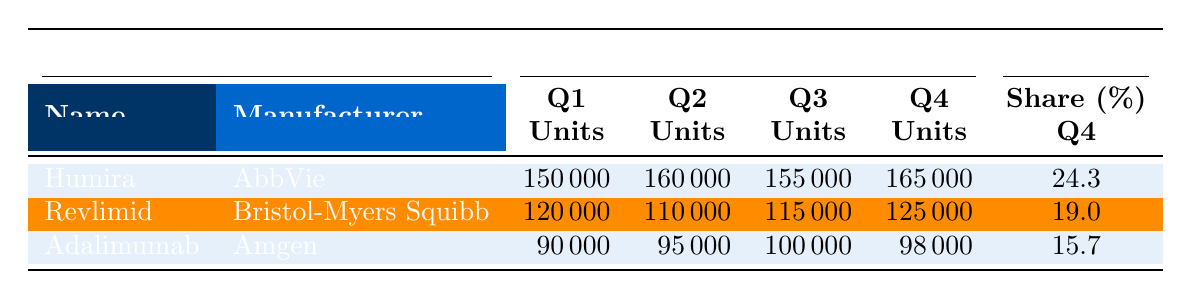What is the sales volume in units for Humira in Q2? The table indicates that the sales volume in units for Humira in Q2 is specifically listed under that quarter's column. The value for Humira in Q2 is 160,000 units.
Answer: 160,000 Which drug had the highest market share in Q4? The table shows that Humira has a market share of 24.3% in Q4, which is higher than the market shares for Revlimid (19.0%) and Adalimumab (15.7%). Therefore, Humira had the highest market share in Q4.
Answer: Humira What is the total sales volume in units for Revlimid over all four quarters? To find the total sales volume of Revlimid, add the units sold in each quarter: 120,000 (Q1) + 110,000 (Q2) + 115,000 (Q3) + 125,000 (Q4) = 470,000 units.
Answer: 470,000 Is the market share for Adalimumab consistent across all quarters? The market share for Adalimumab varies: 14.5% in Q1, 15.2% in Q2, 15.5% in Q3, and 15.7% in Q4. Since these values change, the market share is not consistent across all quarters.
Answer: No What is the percentage increase in sales volume units of Humira from Q1 to Q4? First, find the sales volume in Q1 (150,000 units) and Q4 (165,000 units). The increase is 165,000 - 150,000 = 15,000 units. To find the percentage increase: (15,000 / 150,000) * 100 = 10%.
Answer: 10% Which drug had the lowest sales volume units in Q3? Looking at the Q3 column, the values for each drug are: Humira (155,000), Revlimid (115,000), and Adalimumab (100,000). Adalimumab has the lowest at 100,000 units.
Answer: Adalimumab What is the average sales volume in units for Adalimumab over the four quarters? Add the sales volumes for Adalimumab: 90,000 (Q1) + 95,000 (Q2) + 100,000 (Q3) + 98,000 (Q4) = 382,000. Then, divide by 4 to get the average: 382,000 / 4 = 95,500.
Answer: 95,500 What is the percentage of the total sales volume from Q1 for all drugs? Calculate the total sales volume for Q1: 150,000 + 120,000 + 90,000 = 360,000 units. To find the percentage of Humira's sales volume (150,000) compared to the total: (150,000 / 360,000) * 100 ≈ 41.67%.
Answer: 41.67% Did the average sales volume for Humira increase or decrease from Q1 to Q3? Review the Q1 sales volume of 150,000 units and Q3 sales volume of 155,000 units. Since 155,000 is greater than 150,000, we conclude that it increased.
Answer: Increased 